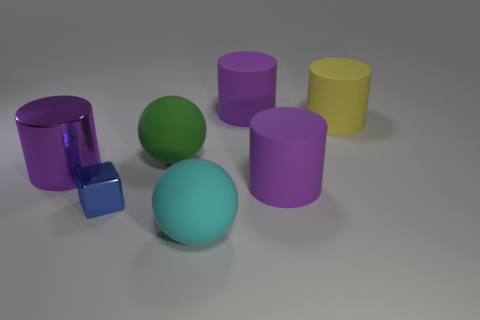What is the shape of the tiny metallic thing?
Your answer should be very brief. Cube. What size is the metal cylinder that is in front of the object behind the yellow matte thing?
Your answer should be very brief. Large. What number of things are tiny blue metal objects or large cyan things?
Your response must be concise. 2. Do the big cyan object and the big green object have the same shape?
Provide a short and direct response. Yes. Is there a thing that has the same material as the yellow cylinder?
Your answer should be very brief. Yes. There is a purple rubber object in front of the big yellow thing; is there a large purple matte cylinder that is to the right of it?
Your answer should be very brief. No. There is a sphere that is in front of the blue cube; is its size the same as the big green rubber thing?
Your response must be concise. Yes. The metallic cylinder has what size?
Offer a very short reply. Large. Is there a large object of the same color as the metallic cylinder?
Make the answer very short. Yes. How many big objects are either metallic cylinders or green balls?
Your answer should be compact. 2. 